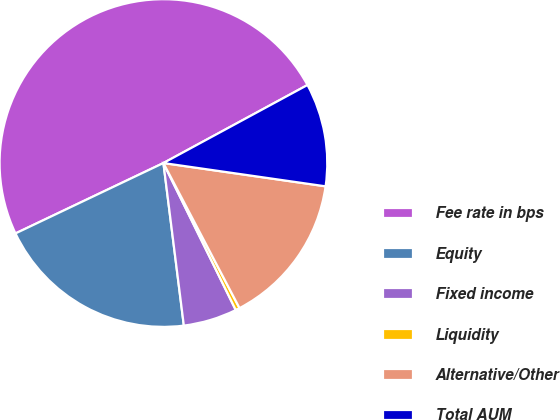Convert chart. <chart><loc_0><loc_0><loc_500><loc_500><pie_chart><fcel>Fee rate in bps<fcel>Equity<fcel>Fixed income<fcel>Liquidity<fcel>Alternative/Other<fcel>Total AUM<nl><fcel>49.17%<fcel>19.92%<fcel>5.29%<fcel>0.41%<fcel>15.04%<fcel>10.17%<nl></chart> 